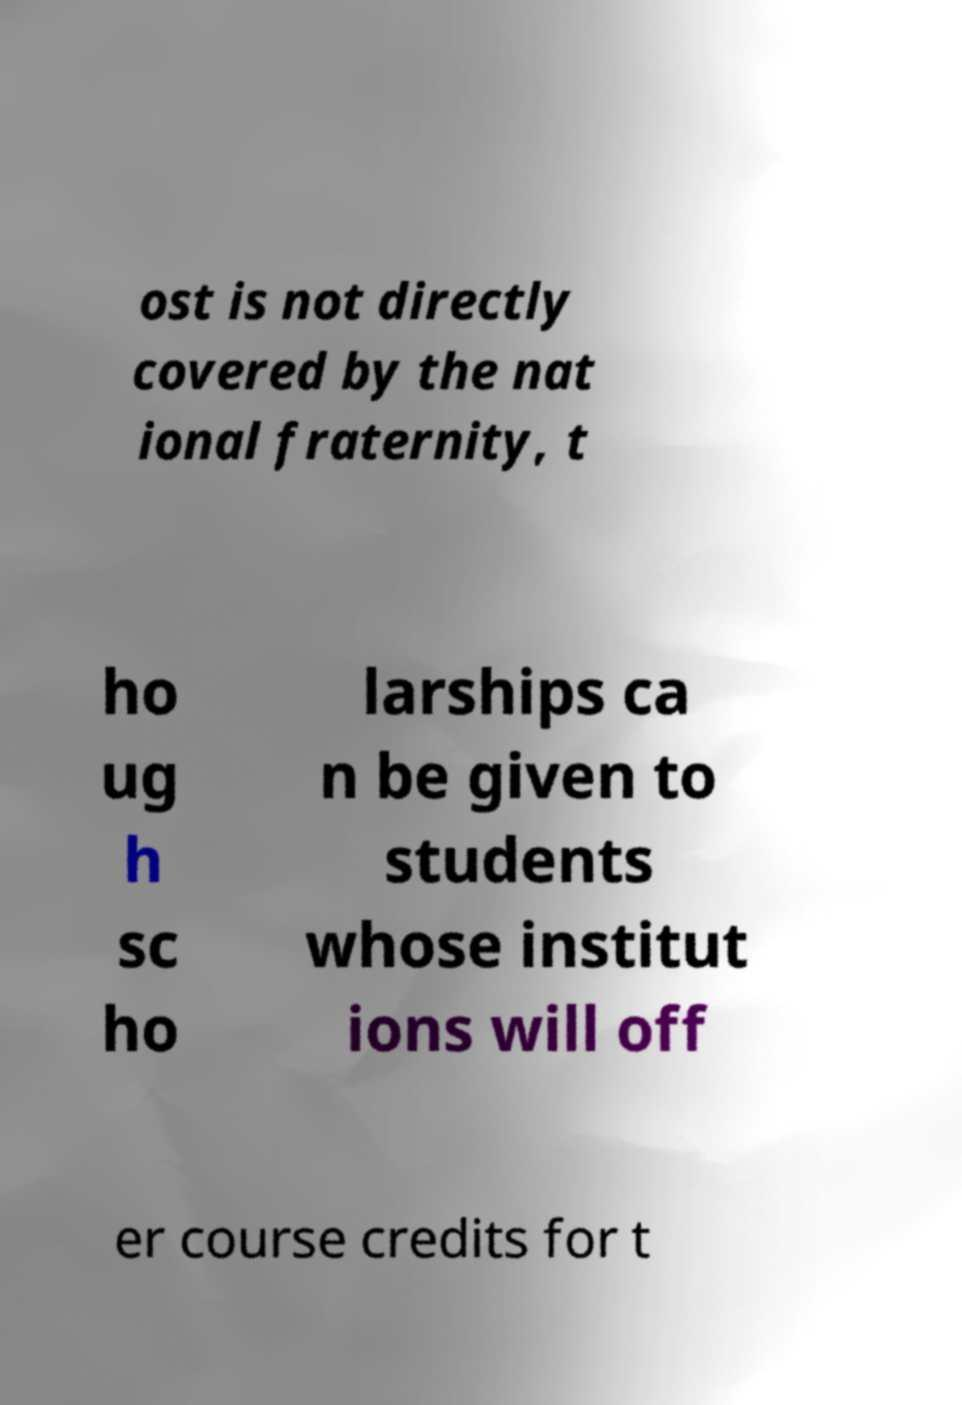There's text embedded in this image that I need extracted. Can you transcribe it verbatim? ost is not directly covered by the nat ional fraternity, t ho ug h sc ho larships ca n be given to students whose institut ions will off er course credits for t 